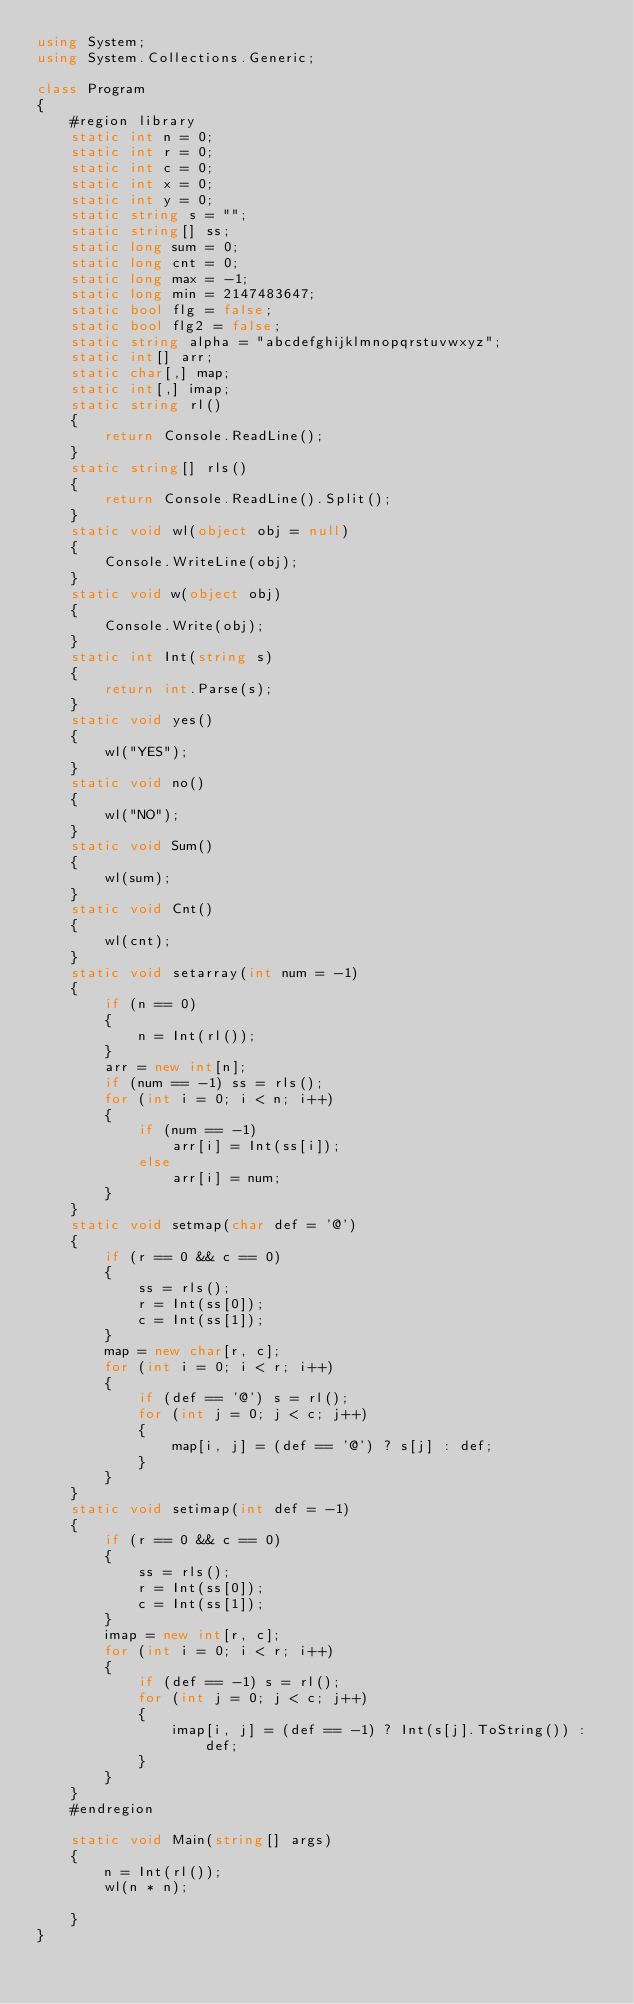Convert code to text. <code><loc_0><loc_0><loc_500><loc_500><_C#_>using System;
using System.Collections.Generic;

class Program
{
    #region library
    static int n = 0;
    static int r = 0;
    static int c = 0;
    static int x = 0;
    static int y = 0;
    static string s = "";
    static string[] ss;
    static long sum = 0;
    static long cnt = 0;
    static long max = -1;
    static long min = 2147483647;
    static bool flg = false;
    static bool flg2 = false;
    static string alpha = "abcdefghijklmnopqrstuvwxyz";
    static int[] arr;
    static char[,] map;
    static int[,] imap;
    static string rl()
    {
        return Console.ReadLine();
    }
    static string[] rls()
    {
        return Console.ReadLine().Split();
    }
    static void wl(object obj = null)
    {
        Console.WriteLine(obj);
    }
    static void w(object obj)
    {
        Console.Write(obj);
    }
    static int Int(string s)
    {
        return int.Parse(s);
    }
    static void yes()
    {
        wl("YES");
    }
    static void no()
    {
        wl("NO");
    }
    static void Sum()
    {
        wl(sum);
    }
    static void Cnt()
    {
        wl(cnt);
    }
    static void setarray(int num = -1)
    {
        if (n == 0)
        {
            n = Int(rl());
        }
        arr = new int[n];
        if (num == -1) ss = rls();
        for (int i = 0; i < n; i++)
        {
            if (num == -1)
                arr[i] = Int(ss[i]);
            else
                arr[i] = num;
        }
    }
    static void setmap(char def = '@')
    {
        if (r == 0 && c == 0)
        {
            ss = rls();
            r = Int(ss[0]);
            c = Int(ss[1]);
        }
        map = new char[r, c];
        for (int i = 0; i < r; i++)
        {
            if (def == '@') s = rl();
            for (int j = 0; j < c; j++)
            {
                map[i, j] = (def == '@') ? s[j] : def;
            }
        }
    }
    static void setimap(int def = -1)
    {
        if (r == 0 && c == 0)
        {
            ss = rls();
            r = Int(ss[0]);
            c = Int(ss[1]);
        }
        imap = new int[r, c];
        for (int i = 0; i < r; i++)
        {
            if (def == -1) s = rl();
            for (int j = 0; j < c; j++)
            {
                imap[i, j] = (def == -1) ? Int(s[j].ToString()) : def;
            }
        }
    }
    #endregion

    static void Main(string[] args)
    {
        n = Int(rl());
        wl(n * n);

    }
}

</code> 